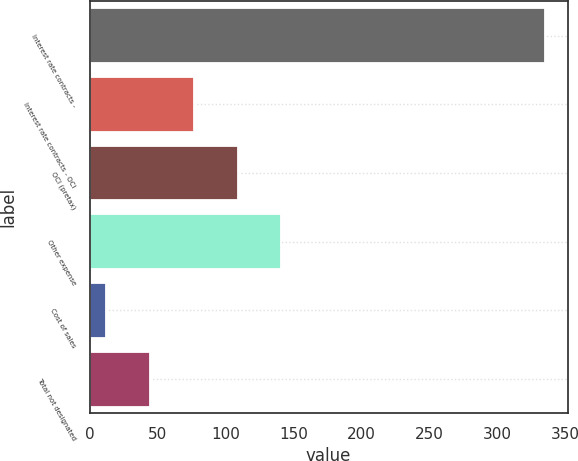<chart> <loc_0><loc_0><loc_500><loc_500><bar_chart><fcel>Interest rate contracts -<fcel>Interest rate contracts - OCI<fcel>OCI (pretax)<fcel>Other expense<fcel>Cost of sales<fcel>Total not designated<nl><fcel>335<fcel>76.6<fcel>108.9<fcel>141.2<fcel>12<fcel>44.3<nl></chart> 